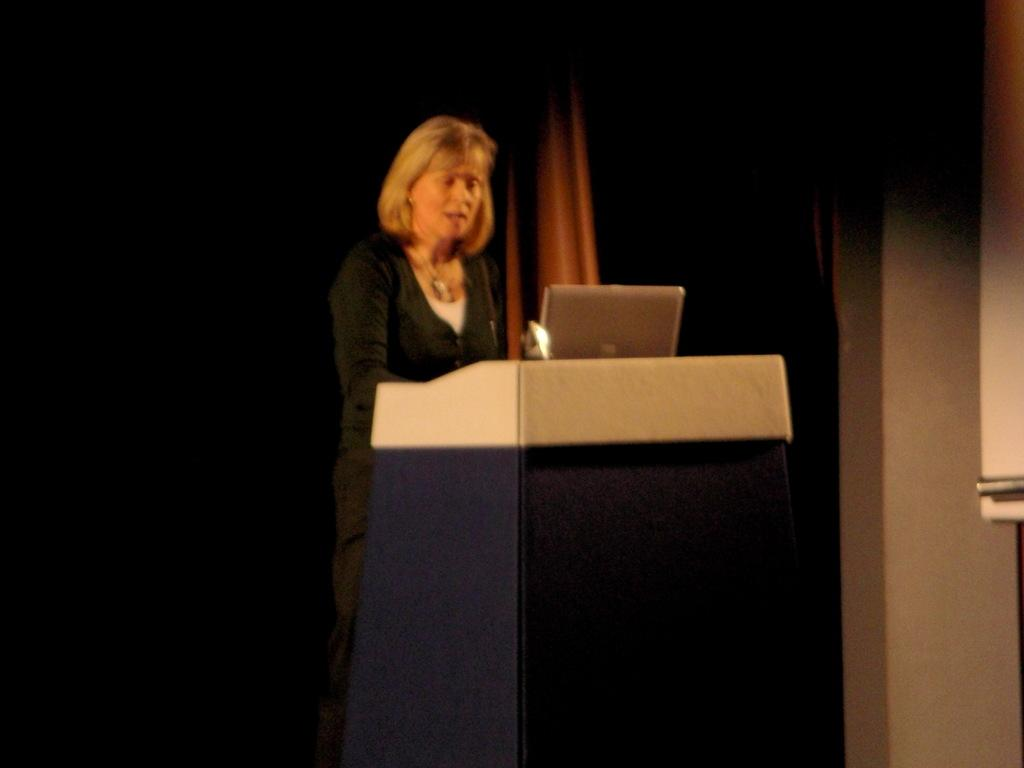Who is the main subject in the image? There is a woman in the image. Where is the woman located in the image? The woman is in the middle of the image. What is the woman standing near in the image? The woman is standing near a podium. What type of sponge is the woman using to clean the podium in the image? There is no sponge present in the image, and the woman is not cleaning the podium. 